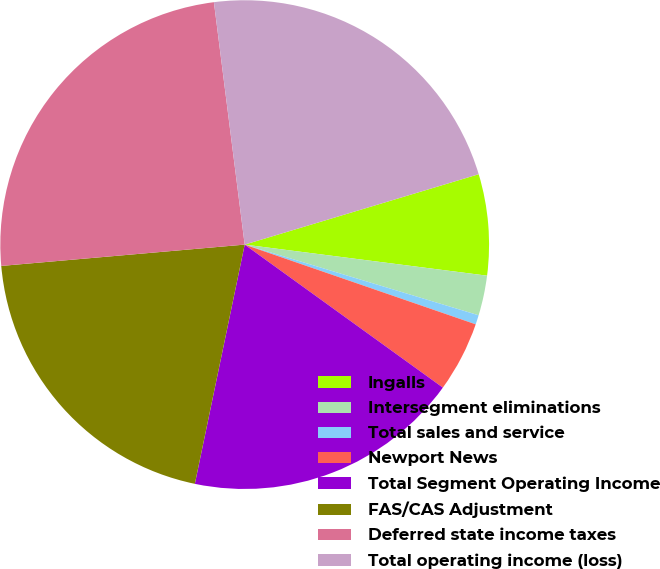<chart> <loc_0><loc_0><loc_500><loc_500><pie_chart><fcel>Ingalls<fcel>Intersegment eliminations<fcel>Total sales and service<fcel>Newport News<fcel>Total Segment Operating Income<fcel>FAS/CAS Adjustment<fcel>Deferred state income taxes<fcel>Total operating income (loss)<nl><fcel>6.68%<fcel>2.64%<fcel>0.62%<fcel>4.66%<fcel>18.32%<fcel>20.34%<fcel>24.38%<fcel>22.36%<nl></chart> 